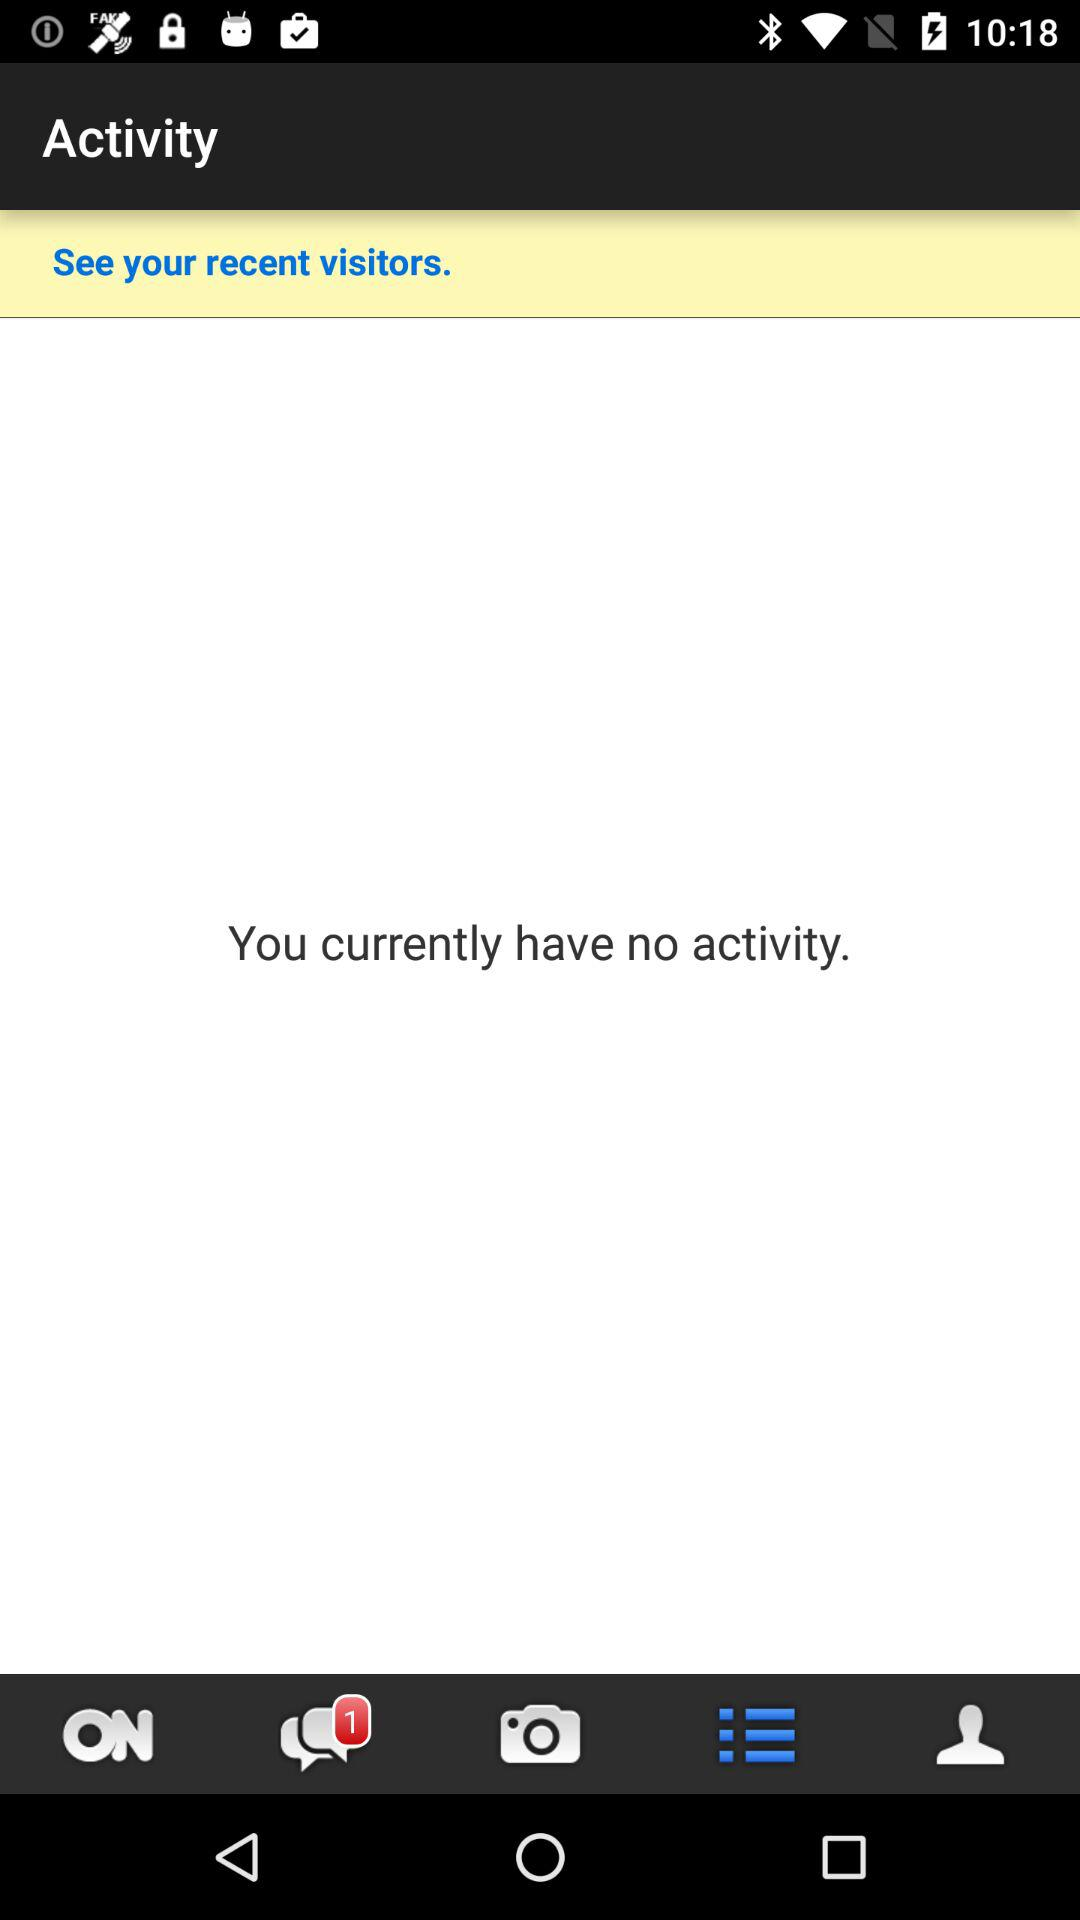Is there any activity? There is no activity. 